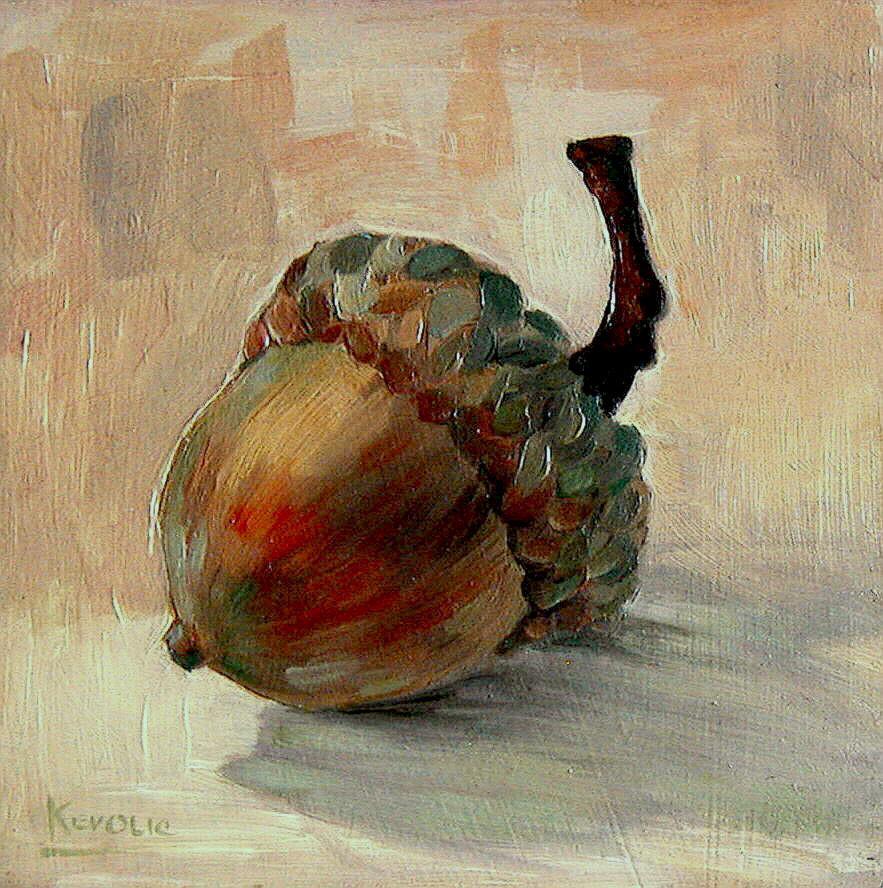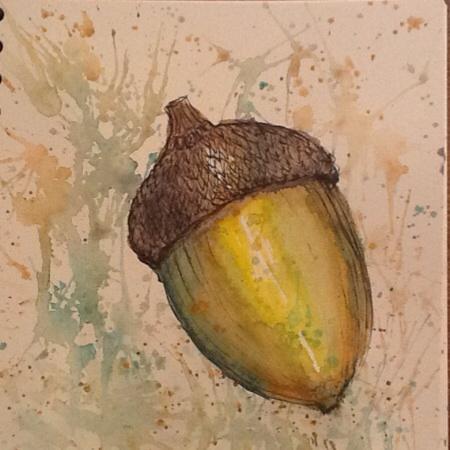The first image is the image on the left, the second image is the image on the right. Examine the images to the left and right. Is the description "Acorns are hanging on the limb yet to fall." accurate? Answer yes or no. No. The first image is the image on the left, the second image is the image on the right. Considering the images on both sides, is "There is only a single acorn it at least one of the images." valid? Answer yes or no. Yes. 